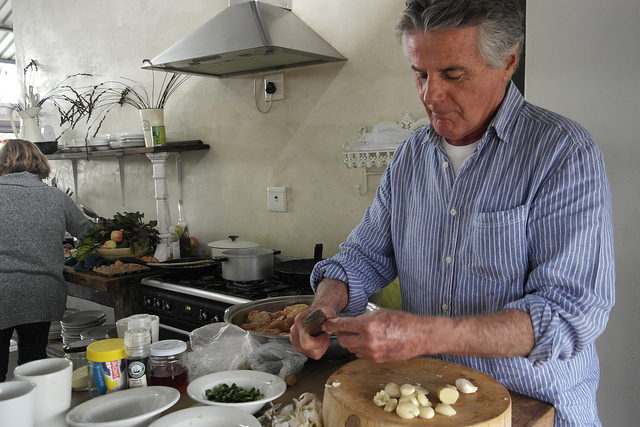<image>What is in the jar with the white lid? I don't know what is in the jar with the white lid. It could be pickles, cherries, salt, food, honey, vinegar, juice or pickle. What is in the jar with the white lid? I don't know what is in the jar with the white lid. It can be seen 'pickles', 'cherries', 'salt', 'food', 'honey', 'vinegar' or 'juice'. 